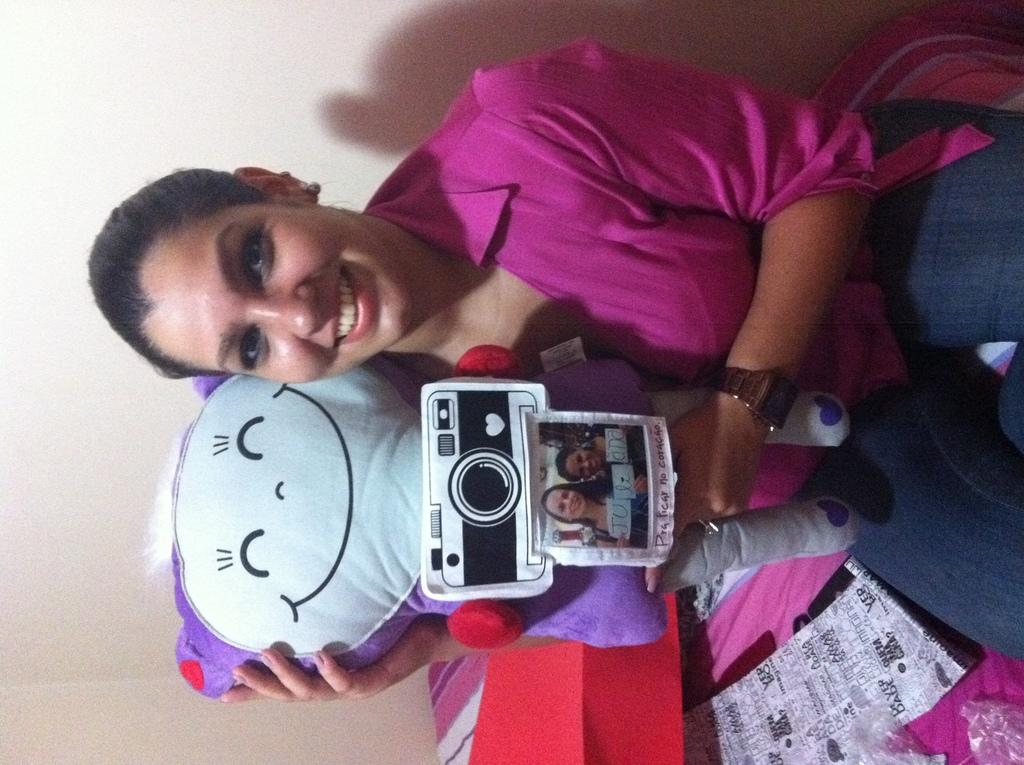In which direction is the image oriented? The image is in a leftward direction. Who is the main subject in the image? There is a woman in the center of the image. What is the woman holding in the image? The woman is holding a toy and a picture. What color is the woman's shirt in the image? The woman is wearing a purple shirt. What type of pants is the woman wearing in the image? The woman is wearing blue jeans. What can be seen behind the woman in the image? There is a wall behind the woman. What type of sign can be seen in the image? There is no sign present in the image. How many planes are visible in the image? There are no planes visible in the image. 